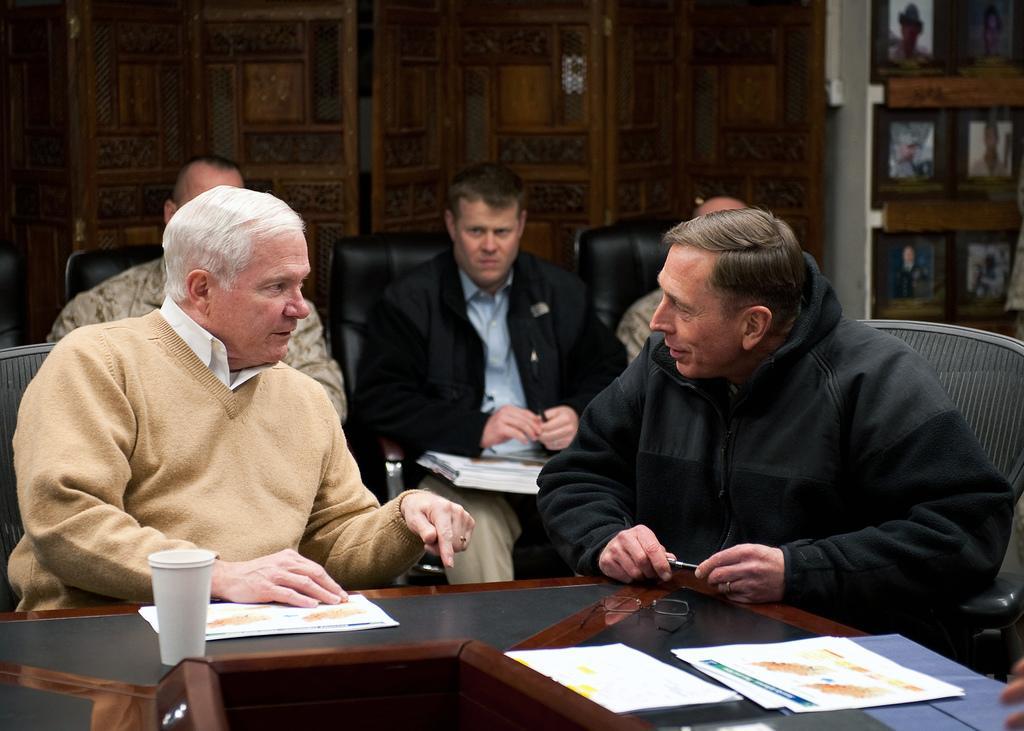Could you give a brief overview of what you see in this image? In front of the picture, we see three men are sitting on the chairs. Both of them are talking to each other. The man on the right side is holding a pen. In front of them, we see a table on which the papers, spectacles and a glass are placed. Behind them, we see three men are sitting on the chairs. The man in the middle is holding a pen and we see the papers. In the background, we see a brown wall. On the right side, we see the photo frames are placed on the wall. 